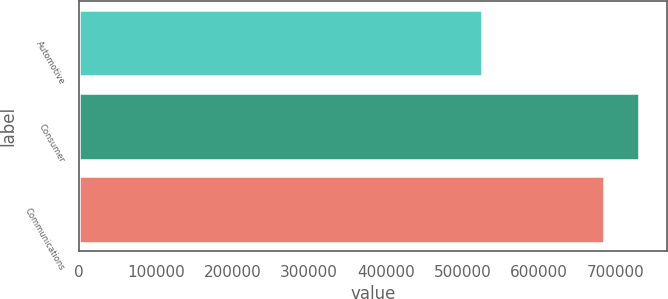Convert chart to OTSL. <chart><loc_0><loc_0><loc_500><loc_500><bar_chart><fcel>Automotive<fcel>Consumer<fcel>Communications<nl><fcel>525893<fcel>729860<fcel>684441<nl></chart> 